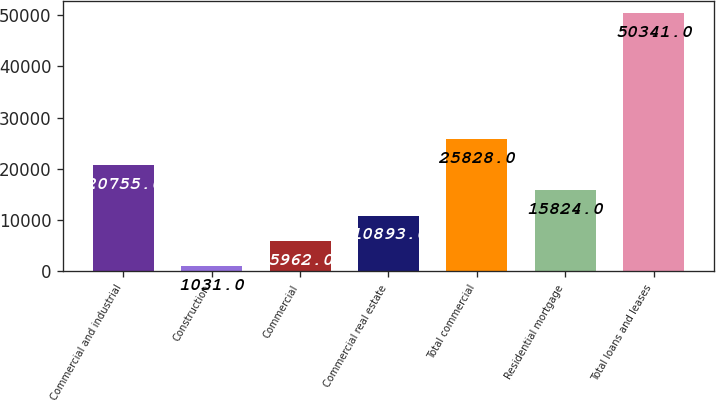<chart> <loc_0><loc_0><loc_500><loc_500><bar_chart><fcel>Commercial and industrial<fcel>Construction<fcel>Commercial<fcel>Commercial real estate<fcel>Total commercial<fcel>Residential mortgage<fcel>Total loans and leases<nl><fcel>20755<fcel>1031<fcel>5962<fcel>10893<fcel>25828<fcel>15824<fcel>50341<nl></chart> 